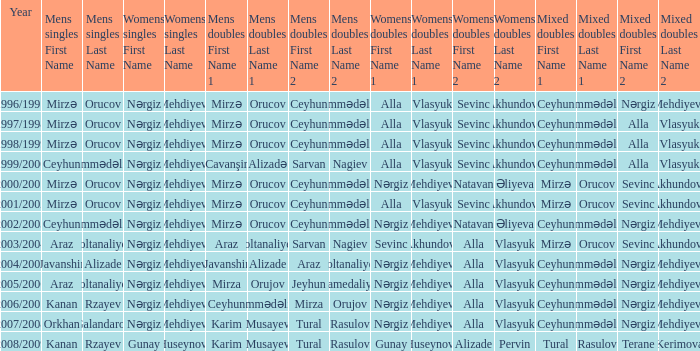What are all values for Womens Doubles in the year 2000/2001? Nərgiz Mehdiyeva Natavan Əliyeva. 